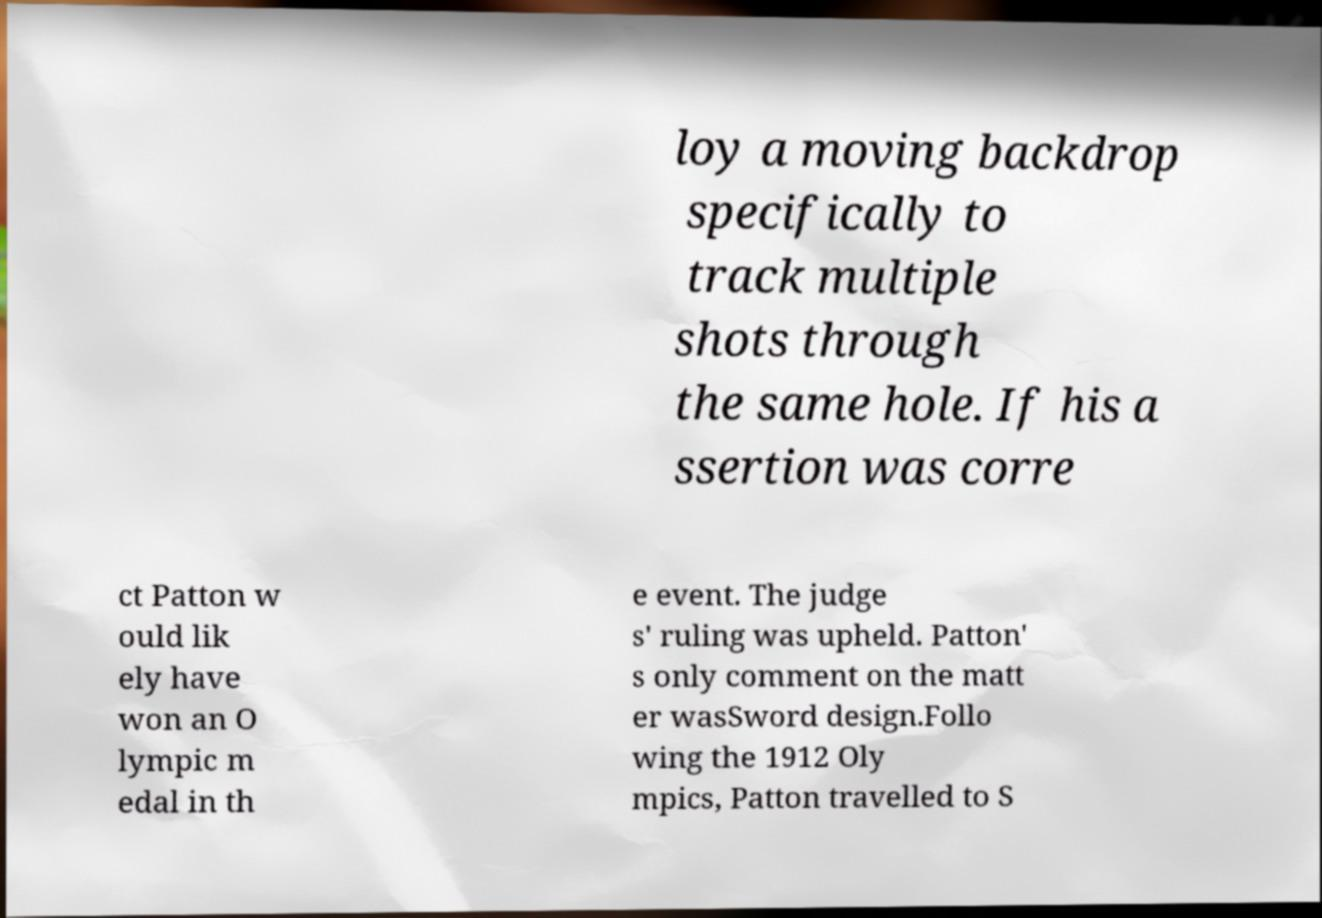Please read and relay the text visible in this image. What does it say? loy a moving backdrop specifically to track multiple shots through the same hole. If his a ssertion was corre ct Patton w ould lik ely have won an O lympic m edal in th e event. The judge s' ruling was upheld. Patton' s only comment on the matt er wasSword design.Follo wing the 1912 Oly mpics, Patton travelled to S 